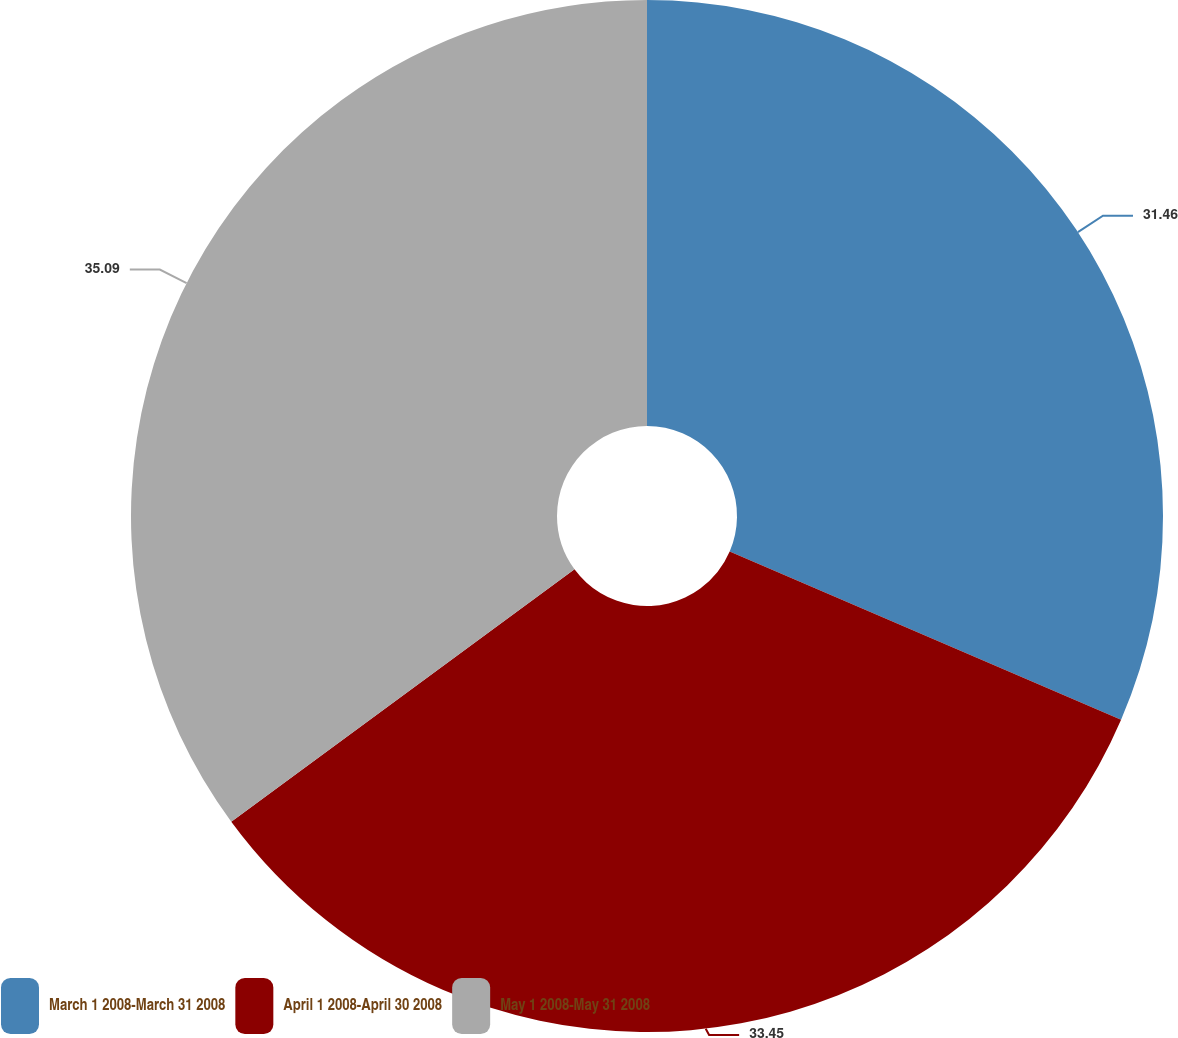Convert chart. <chart><loc_0><loc_0><loc_500><loc_500><pie_chart><fcel>March 1 2008-March 31 2008<fcel>April 1 2008-April 30 2008<fcel>May 1 2008-May 31 2008<nl><fcel>31.46%<fcel>33.45%<fcel>35.09%<nl></chart> 